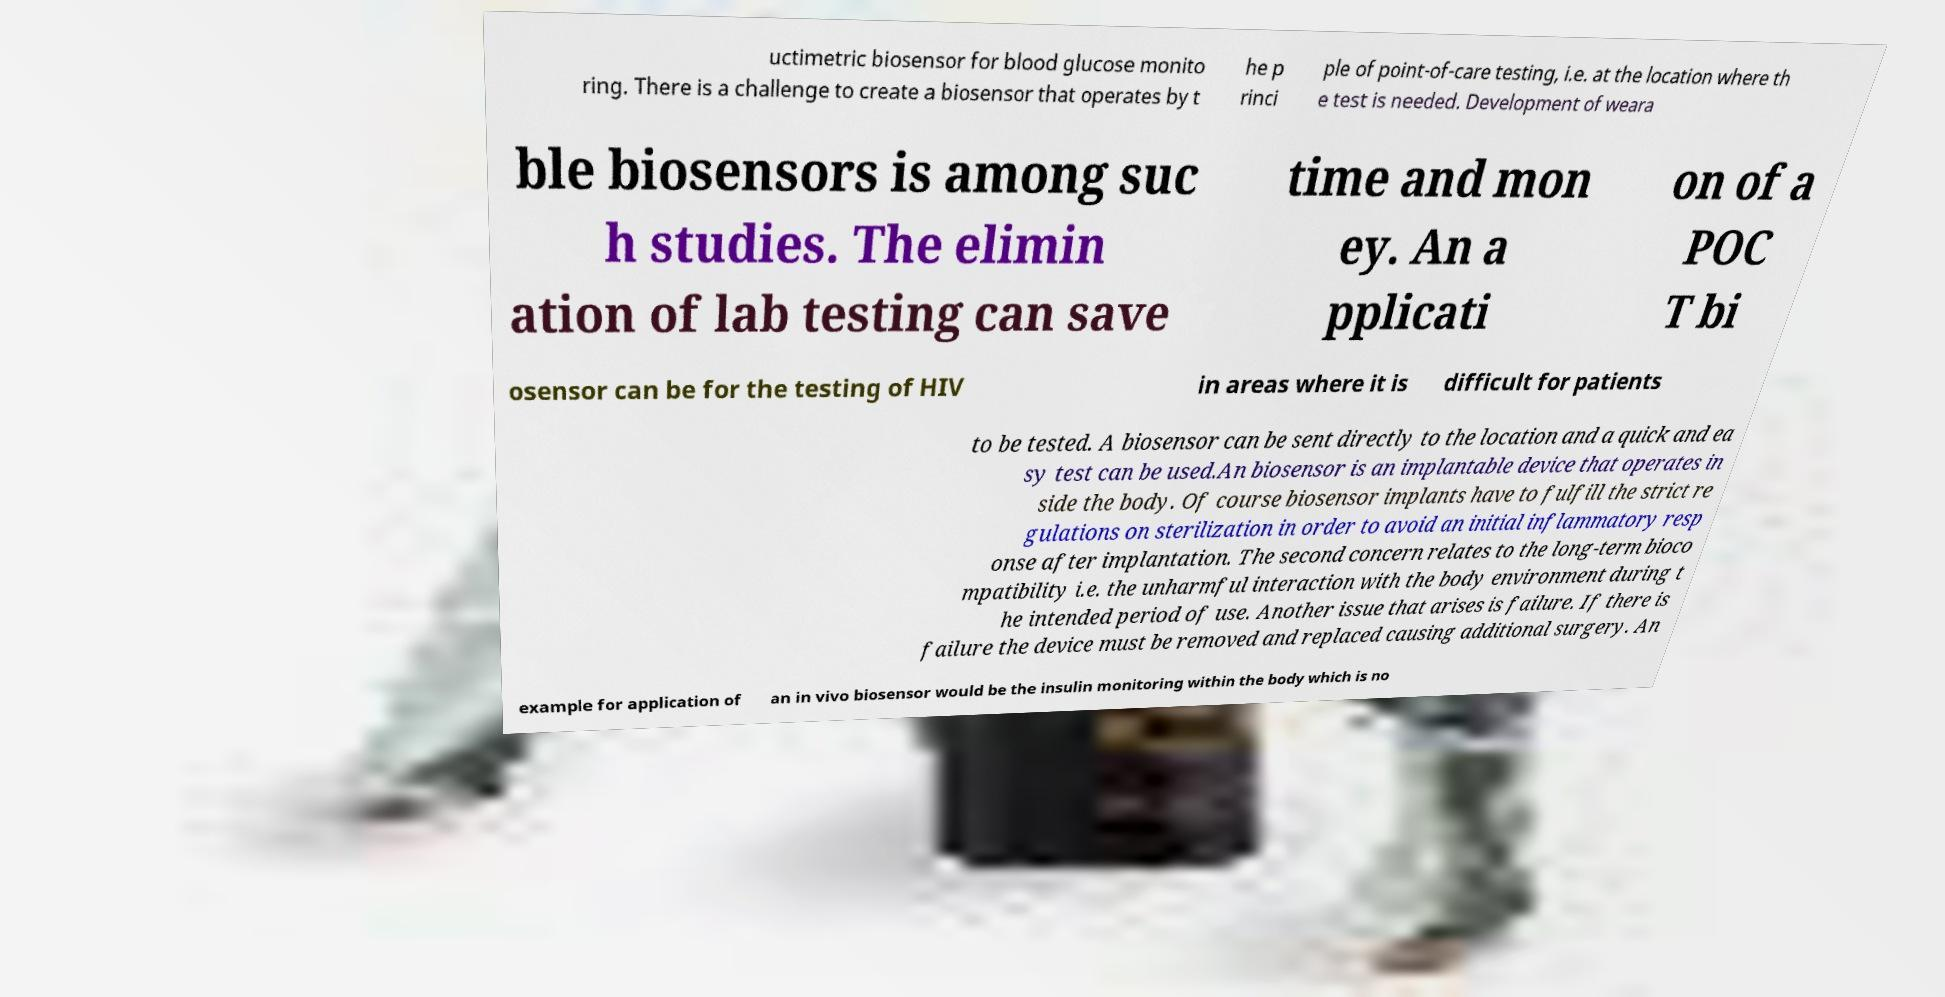There's text embedded in this image that I need extracted. Can you transcribe it verbatim? uctimetric biosensor for blood glucose monito ring. There is a challenge to create a biosensor that operates by t he p rinci ple of point-of-care testing, i.e. at the location where th e test is needed. Development of weara ble biosensors is among suc h studies. The elimin ation of lab testing can save time and mon ey. An a pplicati on of a POC T bi osensor can be for the testing of HIV in areas where it is difficult for patients to be tested. A biosensor can be sent directly to the location and a quick and ea sy test can be used.An biosensor is an implantable device that operates in side the body. Of course biosensor implants have to fulfill the strict re gulations on sterilization in order to avoid an initial inflammatory resp onse after implantation. The second concern relates to the long-term bioco mpatibility i.e. the unharmful interaction with the body environment during t he intended period of use. Another issue that arises is failure. If there is failure the device must be removed and replaced causing additional surgery. An example for application of an in vivo biosensor would be the insulin monitoring within the body which is no 